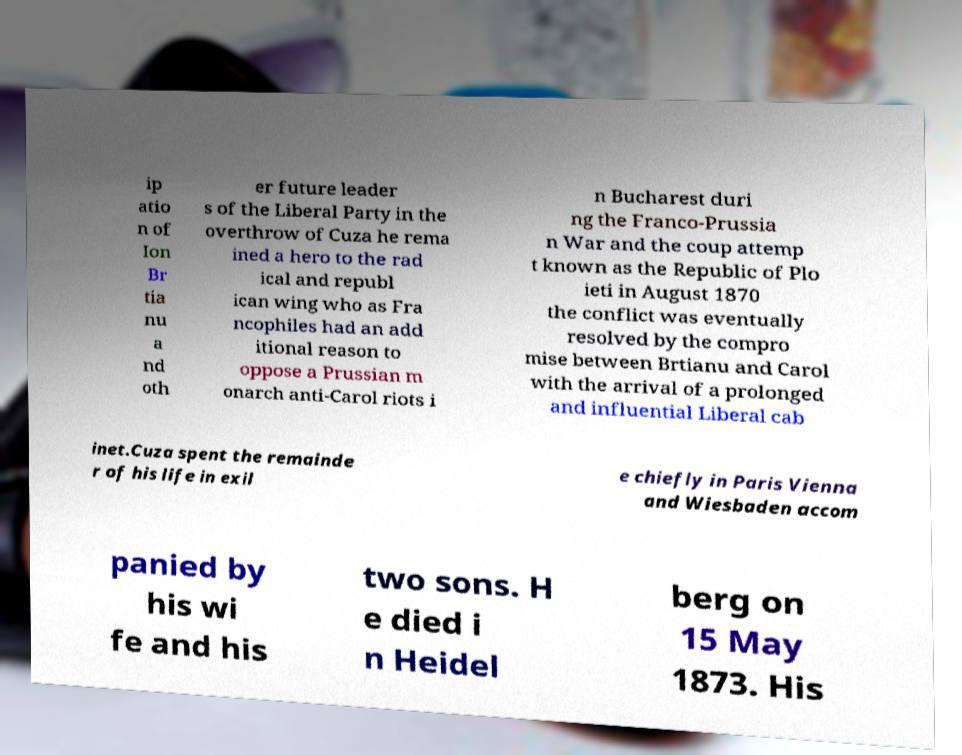Could you assist in decoding the text presented in this image and type it out clearly? ip atio n of Ion Br tia nu a nd oth er future leader s of the Liberal Party in the overthrow of Cuza he rema ined a hero to the rad ical and republ ican wing who as Fra ncophiles had an add itional reason to oppose a Prussian m onarch anti-Carol riots i n Bucharest duri ng the Franco-Prussia n War and the coup attemp t known as the Republic of Plo ieti in August 1870 the conflict was eventually resolved by the compro mise between Brtianu and Carol with the arrival of a prolonged and influential Liberal cab inet.Cuza spent the remainde r of his life in exil e chiefly in Paris Vienna and Wiesbaden accom panied by his wi fe and his two sons. H e died i n Heidel berg on 15 May 1873. His 